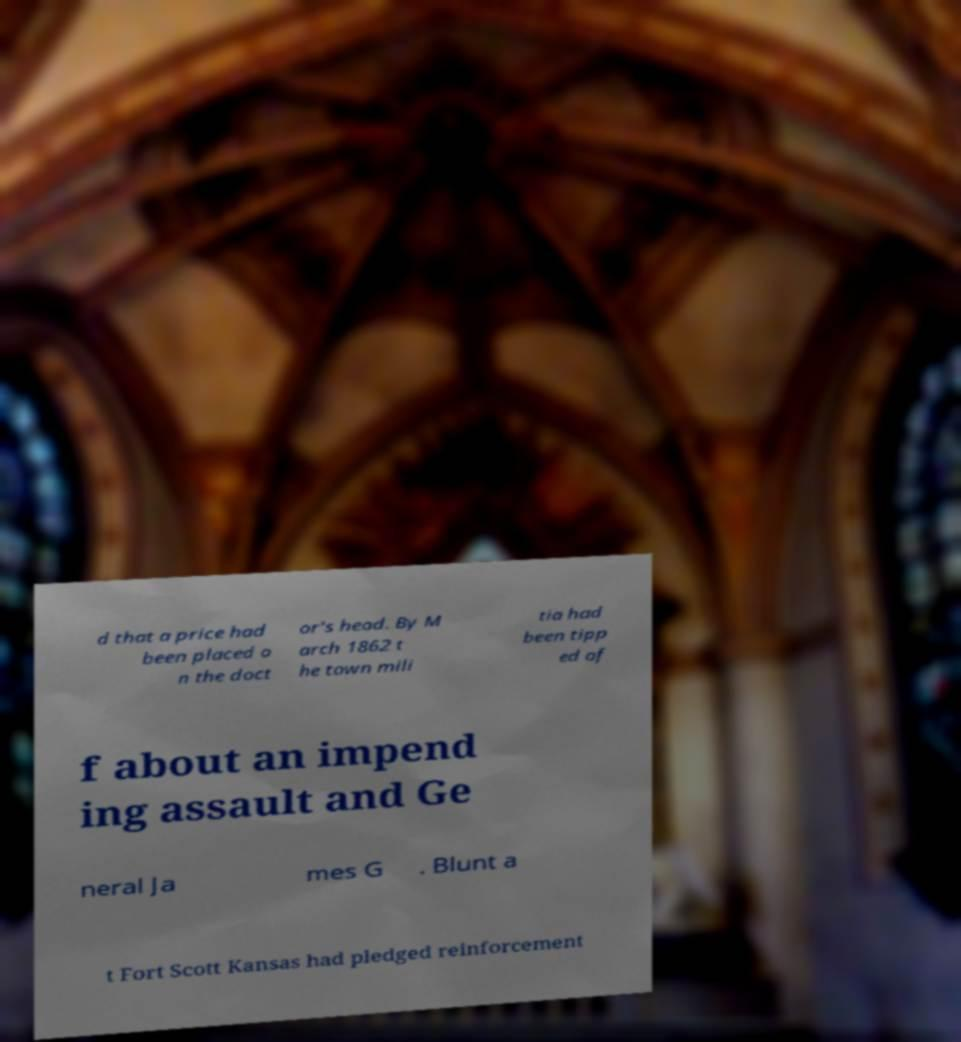Please read and relay the text visible in this image. What does it say? d that a price had been placed o n the doct or's head. By M arch 1862 t he town mili tia had been tipp ed of f about an impend ing assault and Ge neral Ja mes G . Blunt a t Fort Scott Kansas had pledged reinforcement 